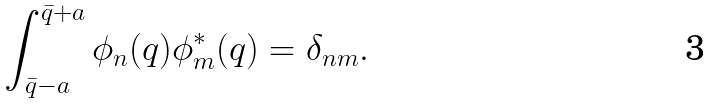<formula> <loc_0><loc_0><loc_500><loc_500>\int _ { \bar { q } - a } ^ { \bar { q } + a } \phi _ { n } ( q ) \phi _ { m } ^ { * } ( q ) = \delta _ { n m } .</formula> 